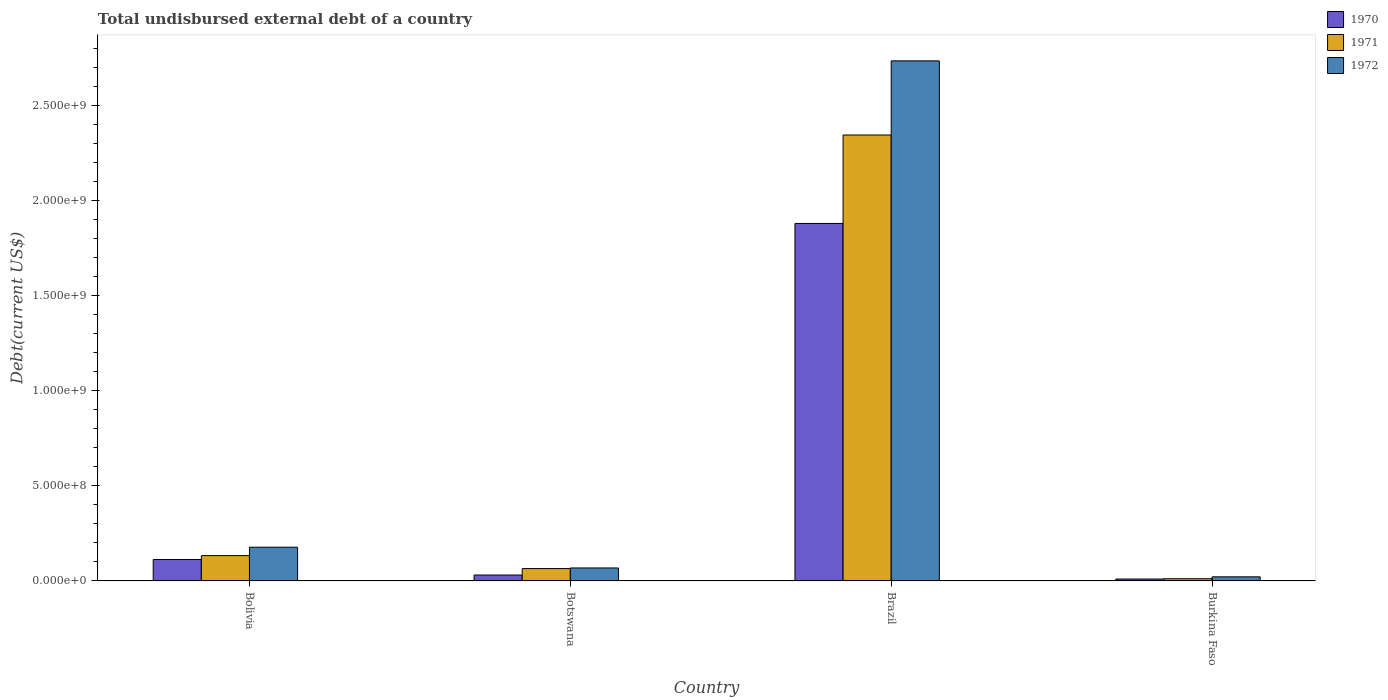How many bars are there on the 3rd tick from the left?
Offer a very short reply. 3. How many bars are there on the 4th tick from the right?
Offer a very short reply. 3. What is the total undisbursed external debt in 1971 in Botswana?
Keep it short and to the point. 6.50e+07. Across all countries, what is the maximum total undisbursed external debt in 1971?
Make the answer very short. 2.34e+09. Across all countries, what is the minimum total undisbursed external debt in 1971?
Give a very brief answer. 1.16e+07. In which country was the total undisbursed external debt in 1972 minimum?
Offer a very short reply. Burkina Faso. What is the total total undisbursed external debt in 1970 in the graph?
Your answer should be very brief. 2.03e+09. What is the difference between the total undisbursed external debt in 1970 in Botswana and that in Brazil?
Keep it short and to the point. -1.85e+09. What is the difference between the total undisbursed external debt in 1970 in Burkina Faso and the total undisbursed external debt in 1972 in Brazil?
Provide a short and direct response. -2.72e+09. What is the average total undisbursed external debt in 1971 per country?
Your response must be concise. 6.38e+08. What is the difference between the total undisbursed external debt of/in 1972 and total undisbursed external debt of/in 1970 in Botswana?
Make the answer very short. 3.72e+07. What is the ratio of the total undisbursed external debt in 1971 in Bolivia to that in Burkina Faso?
Provide a short and direct response. 11.44. Is the difference between the total undisbursed external debt in 1972 in Brazil and Burkina Faso greater than the difference between the total undisbursed external debt in 1970 in Brazil and Burkina Faso?
Your answer should be compact. Yes. What is the difference between the highest and the second highest total undisbursed external debt in 1972?
Provide a succinct answer. 2.56e+09. What is the difference between the highest and the lowest total undisbursed external debt in 1970?
Provide a succinct answer. 1.87e+09. In how many countries, is the total undisbursed external debt in 1971 greater than the average total undisbursed external debt in 1971 taken over all countries?
Offer a terse response. 1. Is the sum of the total undisbursed external debt in 1972 in Bolivia and Botswana greater than the maximum total undisbursed external debt in 1971 across all countries?
Your answer should be compact. No. Is it the case that in every country, the sum of the total undisbursed external debt in 1970 and total undisbursed external debt in 1971 is greater than the total undisbursed external debt in 1972?
Offer a very short reply. Yes. What is the title of the graph?
Give a very brief answer. Total undisbursed external debt of a country. Does "2013" appear as one of the legend labels in the graph?
Give a very brief answer. No. What is the label or title of the X-axis?
Offer a terse response. Country. What is the label or title of the Y-axis?
Ensure brevity in your answer.  Debt(current US$). What is the Debt(current US$) of 1970 in Bolivia?
Offer a terse response. 1.13e+08. What is the Debt(current US$) in 1971 in Bolivia?
Your answer should be compact. 1.33e+08. What is the Debt(current US$) of 1972 in Bolivia?
Keep it short and to the point. 1.77e+08. What is the Debt(current US$) of 1970 in Botswana?
Provide a short and direct response. 3.11e+07. What is the Debt(current US$) of 1971 in Botswana?
Offer a very short reply. 6.50e+07. What is the Debt(current US$) of 1972 in Botswana?
Keep it short and to the point. 6.83e+07. What is the Debt(current US$) of 1970 in Brazil?
Give a very brief answer. 1.88e+09. What is the Debt(current US$) of 1971 in Brazil?
Make the answer very short. 2.34e+09. What is the Debt(current US$) of 1972 in Brazil?
Give a very brief answer. 2.73e+09. What is the Debt(current US$) in 1970 in Burkina Faso?
Provide a short and direct response. 1.01e+07. What is the Debt(current US$) in 1971 in Burkina Faso?
Offer a terse response. 1.16e+07. What is the Debt(current US$) in 1972 in Burkina Faso?
Make the answer very short. 2.16e+07. Across all countries, what is the maximum Debt(current US$) in 1970?
Provide a succinct answer. 1.88e+09. Across all countries, what is the maximum Debt(current US$) of 1971?
Provide a short and direct response. 2.34e+09. Across all countries, what is the maximum Debt(current US$) in 1972?
Offer a terse response. 2.73e+09. Across all countries, what is the minimum Debt(current US$) of 1970?
Provide a short and direct response. 1.01e+07. Across all countries, what is the minimum Debt(current US$) of 1971?
Keep it short and to the point. 1.16e+07. Across all countries, what is the minimum Debt(current US$) in 1972?
Offer a terse response. 2.16e+07. What is the total Debt(current US$) of 1970 in the graph?
Make the answer very short. 2.03e+09. What is the total Debt(current US$) in 1971 in the graph?
Offer a very short reply. 2.55e+09. What is the total Debt(current US$) of 1972 in the graph?
Provide a short and direct response. 3.00e+09. What is the difference between the Debt(current US$) in 1970 in Bolivia and that in Botswana?
Your response must be concise. 8.15e+07. What is the difference between the Debt(current US$) in 1971 in Bolivia and that in Botswana?
Make the answer very short. 6.82e+07. What is the difference between the Debt(current US$) of 1972 in Bolivia and that in Botswana?
Keep it short and to the point. 1.09e+08. What is the difference between the Debt(current US$) of 1970 in Bolivia and that in Brazil?
Your response must be concise. -1.77e+09. What is the difference between the Debt(current US$) in 1971 in Bolivia and that in Brazil?
Your answer should be compact. -2.21e+09. What is the difference between the Debt(current US$) of 1972 in Bolivia and that in Brazil?
Keep it short and to the point. -2.56e+09. What is the difference between the Debt(current US$) in 1970 in Bolivia and that in Burkina Faso?
Your answer should be very brief. 1.03e+08. What is the difference between the Debt(current US$) in 1971 in Bolivia and that in Burkina Faso?
Provide a succinct answer. 1.22e+08. What is the difference between the Debt(current US$) in 1972 in Bolivia and that in Burkina Faso?
Keep it short and to the point. 1.56e+08. What is the difference between the Debt(current US$) in 1970 in Botswana and that in Brazil?
Ensure brevity in your answer.  -1.85e+09. What is the difference between the Debt(current US$) in 1971 in Botswana and that in Brazil?
Give a very brief answer. -2.28e+09. What is the difference between the Debt(current US$) of 1972 in Botswana and that in Brazil?
Your answer should be very brief. -2.67e+09. What is the difference between the Debt(current US$) in 1970 in Botswana and that in Burkina Faso?
Keep it short and to the point. 2.10e+07. What is the difference between the Debt(current US$) in 1971 in Botswana and that in Burkina Faso?
Make the answer very short. 5.34e+07. What is the difference between the Debt(current US$) in 1972 in Botswana and that in Burkina Faso?
Provide a succinct answer. 4.67e+07. What is the difference between the Debt(current US$) of 1970 in Brazil and that in Burkina Faso?
Provide a short and direct response. 1.87e+09. What is the difference between the Debt(current US$) in 1971 in Brazil and that in Burkina Faso?
Ensure brevity in your answer.  2.33e+09. What is the difference between the Debt(current US$) of 1972 in Brazil and that in Burkina Faso?
Provide a succinct answer. 2.71e+09. What is the difference between the Debt(current US$) of 1970 in Bolivia and the Debt(current US$) of 1971 in Botswana?
Make the answer very short. 4.76e+07. What is the difference between the Debt(current US$) of 1970 in Bolivia and the Debt(current US$) of 1972 in Botswana?
Offer a terse response. 4.43e+07. What is the difference between the Debt(current US$) of 1971 in Bolivia and the Debt(current US$) of 1972 in Botswana?
Offer a terse response. 6.49e+07. What is the difference between the Debt(current US$) of 1970 in Bolivia and the Debt(current US$) of 1971 in Brazil?
Your response must be concise. -2.23e+09. What is the difference between the Debt(current US$) in 1970 in Bolivia and the Debt(current US$) in 1972 in Brazil?
Give a very brief answer. -2.62e+09. What is the difference between the Debt(current US$) of 1971 in Bolivia and the Debt(current US$) of 1972 in Brazil?
Ensure brevity in your answer.  -2.60e+09. What is the difference between the Debt(current US$) of 1970 in Bolivia and the Debt(current US$) of 1971 in Burkina Faso?
Your response must be concise. 1.01e+08. What is the difference between the Debt(current US$) of 1970 in Bolivia and the Debt(current US$) of 1972 in Burkina Faso?
Provide a short and direct response. 9.10e+07. What is the difference between the Debt(current US$) in 1971 in Bolivia and the Debt(current US$) in 1972 in Burkina Faso?
Offer a terse response. 1.12e+08. What is the difference between the Debt(current US$) in 1970 in Botswana and the Debt(current US$) in 1971 in Brazil?
Keep it short and to the point. -2.31e+09. What is the difference between the Debt(current US$) in 1970 in Botswana and the Debt(current US$) in 1972 in Brazil?
Give a very brief answer. -2.70e+09. What is the difference between the Debt(current US$) in 1971 in Botswana and the Debt(current US$) in 1972 in Brazil?
Your response must be concise. -2.67e+09. What is the difference between the Debt(current US$) of 1970 in Botswana and the Debt(current US$) of 1971 in Burkina Faso?
Keep it short and to the point. 1.94e+07. What is the difference between the Debt(current US$) of 1970 in Botswana and the Debt(current US$) of 1972 in Burkina Faso?
Provide a succinct answer. 9.50e+06. What is the difference between the Debt(current US$) of 1971 in Botswana and the Debt(current US$) of 1972 in Burkina Faso?
Give a very brief answer. 4.34e+07. What is the difference between the Debt(current US$) of 1970 in Brazil and the Debt(current US$) of 1971 in Burkina Faso?
Ensure brevity in your answer.  1.87e+09. What is the difference between the Debt(current US$) in 1970 in Brazil and the Debt(current US$) in 1972 in Burkina Faso?
Your answer should be compact. 1.86e+09. What is the difference between the Debt(current US$) in 1971 in Brazil and the Debt(current US$) in 1972 in Burkina Faso?
Provide a short and direct response. 2.32e+09. What is the average Debt(current US$) of 1970 per country?
Your response must be concise. 5.08e+08. What is the average Debt(current US$) of 1971 per country?
Your response must be concise. 6.38e+08. What is the average Debt(current US$) of 1972 per country?
Make the answer very short. 7.50e+08. What is the difference between the Debt(current US$) of 1970 and Debt(current US$) of 1971 in Bolivia?
Your answer should be compact. -2.06e+07. What is the difference between the Debt(current US$) in 1970 and Debt(current US$) in 1972 in Bolivia?
Give a very brief answer. -6.47e+07. What is the difference between the Debt(current US$) in 1971 and Debt(current US$) in 1972 in Bolivia?
Make the answer very short. -4.41e+07. What is the difference between the Debt(current US$) of 1970 and Debt(current US$) of 1971 in Botswana?
Your response must be concise. -3.39e+07. What is the difference between the Debt(current US$) in 1970 and Debt(current US$) in 1972 in Botswana?
Ensure brevity in your answer.  -3.72e+07. What is the difference between the Debt(current US$) in 1971 and Debt(current US$) in 1972 in Botswana?
Give a very brief answer. -3.24e+06. What is the difference between the Debt(current US$) of 1970 and Debt(current US$) of 1971 in Brazil?
Keep it short and to the point. -4.65e+08. What is the difference between the Debt(current US$) of 1970 and Debt(current US$) of 1972 in Brazil?
Your response must be concise. -8.55e+08. What is the difference between the Debt(current US$) in 1971 and Debt(current US$) in 1972 in Brazil?
Your response must be concise. -3.90e+08. What is the difference between the Debt(current US$) of 1970 and Debt(current US$) of 1971 in Burkina Faso?
Keep it short and to the point. -1.58e+06. What is the difference between the Debt(current US$) of 1970 and Debt(current US$) of 1972 in Burkina Faso?
Give a very brief answer. -1.15e+07. What is the difference between the Debt(current US$) of 1971 and Debt(current US$) of 1972 in Burkina Faso?
Your answer should be compact. -9.93e+06. What is the ratio of the Debt(current US$) in 1970 in Bolivia to that in Botswana?
Provide a succinct answer. 3.62. What is the ratio of the Debt(current US$) in 1971 in Bolivia to that in Botswana?
Ensure brevity in your answer.  2.05. What is the ratio of the Debt(current US$) in 1972 in Bolivia to that in Botswana?
Ensure brevity in your answer.  2.6. What is the ratio of the Debt(current US$) in 1970 in Bolivia to that in Brazil?
Make the answer very short. 0.06. What is the ratio of the Debt(current US$) in 1971 in Bolivia to that in Brazil?
Your answer should be very brief. 0.06. What is the ratio of the Debt(current US$) of 1972 in Bolivia to that in Brazil?
Offer a terse response. 0.06. What is the ratio of the Debt(current US$) of 1970 in Bolivia to that in Burkina Faso?
Offer a terse response. 11.19. What is the ratio of the Debt(current US$) in 1971 in Bolivia to that in Burkina Faso?
Ensure brevity in your answer.  11.44. What is the ratio of the Debt(current US$) of 1972 in Bolivia to that in Burkina Faso?
Make the answer very short. 8.22. What is the ratio of the Debt(current US$) of 1970 in Botswana to that in Brazil?
Provide a short and direct response. 0.02. What is the ratio of the Debt(current US$) in 1971 in Botswana to that in Brazil?
Keep it short and to the point. 0.03. What is the ratio of the Debt(current US$) of 1972 in Botswana to that in Brazil?
Your answer should be compact. 0.03. What is the ratio of the Debt(current US$) in 1970 in Botswana to that in Burkina Faso?
Keep it short and to the point. 3.09. What is the ratio of the Debt(current US$) in 1971 in Botswana to that in Burkina Faso?
Give a very brief answer. 5.58. What is the ratio of the Debt(current US$) in 1972 in Botswana to that in Burkina Faso?
Your response must be concise. 3.16. What is the ratio of the Debt(current US$) in 1970 in Brazil to that in Burkina Faso?
Your answer should be very brief. 186.68. What is the ratio of the Debt(current US$) in 1971 in Brazil to that in Burkina Faso?
Make the answer very short. 201.33. What is the ratio of the Debt(current US$) in 1972 in Brazil to that in Burkina Faso?
Offer a terse response. 126.69. What is the difference between the highest and the second highest Debt(current US$) of 1970?
Provide a succinct answer. 1.77e+09. What is the difference between the highest and the second highest Debt(current US$) of 1971?
Your response must be concise. 2.21e+09. What is the difference between the highest and the second highest Debt(current US$) in 1972?
Provide a succinct answer. 2.56e+09. What is the difference between the highest and the lowest Debt(current US$) in 1970?
Offer a terse response. 1.87e+09. What is the difference between the highest and the lowest Debt(current US$) in 1971?
Provide a short and direct response. 2.33e+09. What is the difference between the highest and the lowest Debt(current US$) of 1972?
Keep it short and to the point. 2.71e+09. 